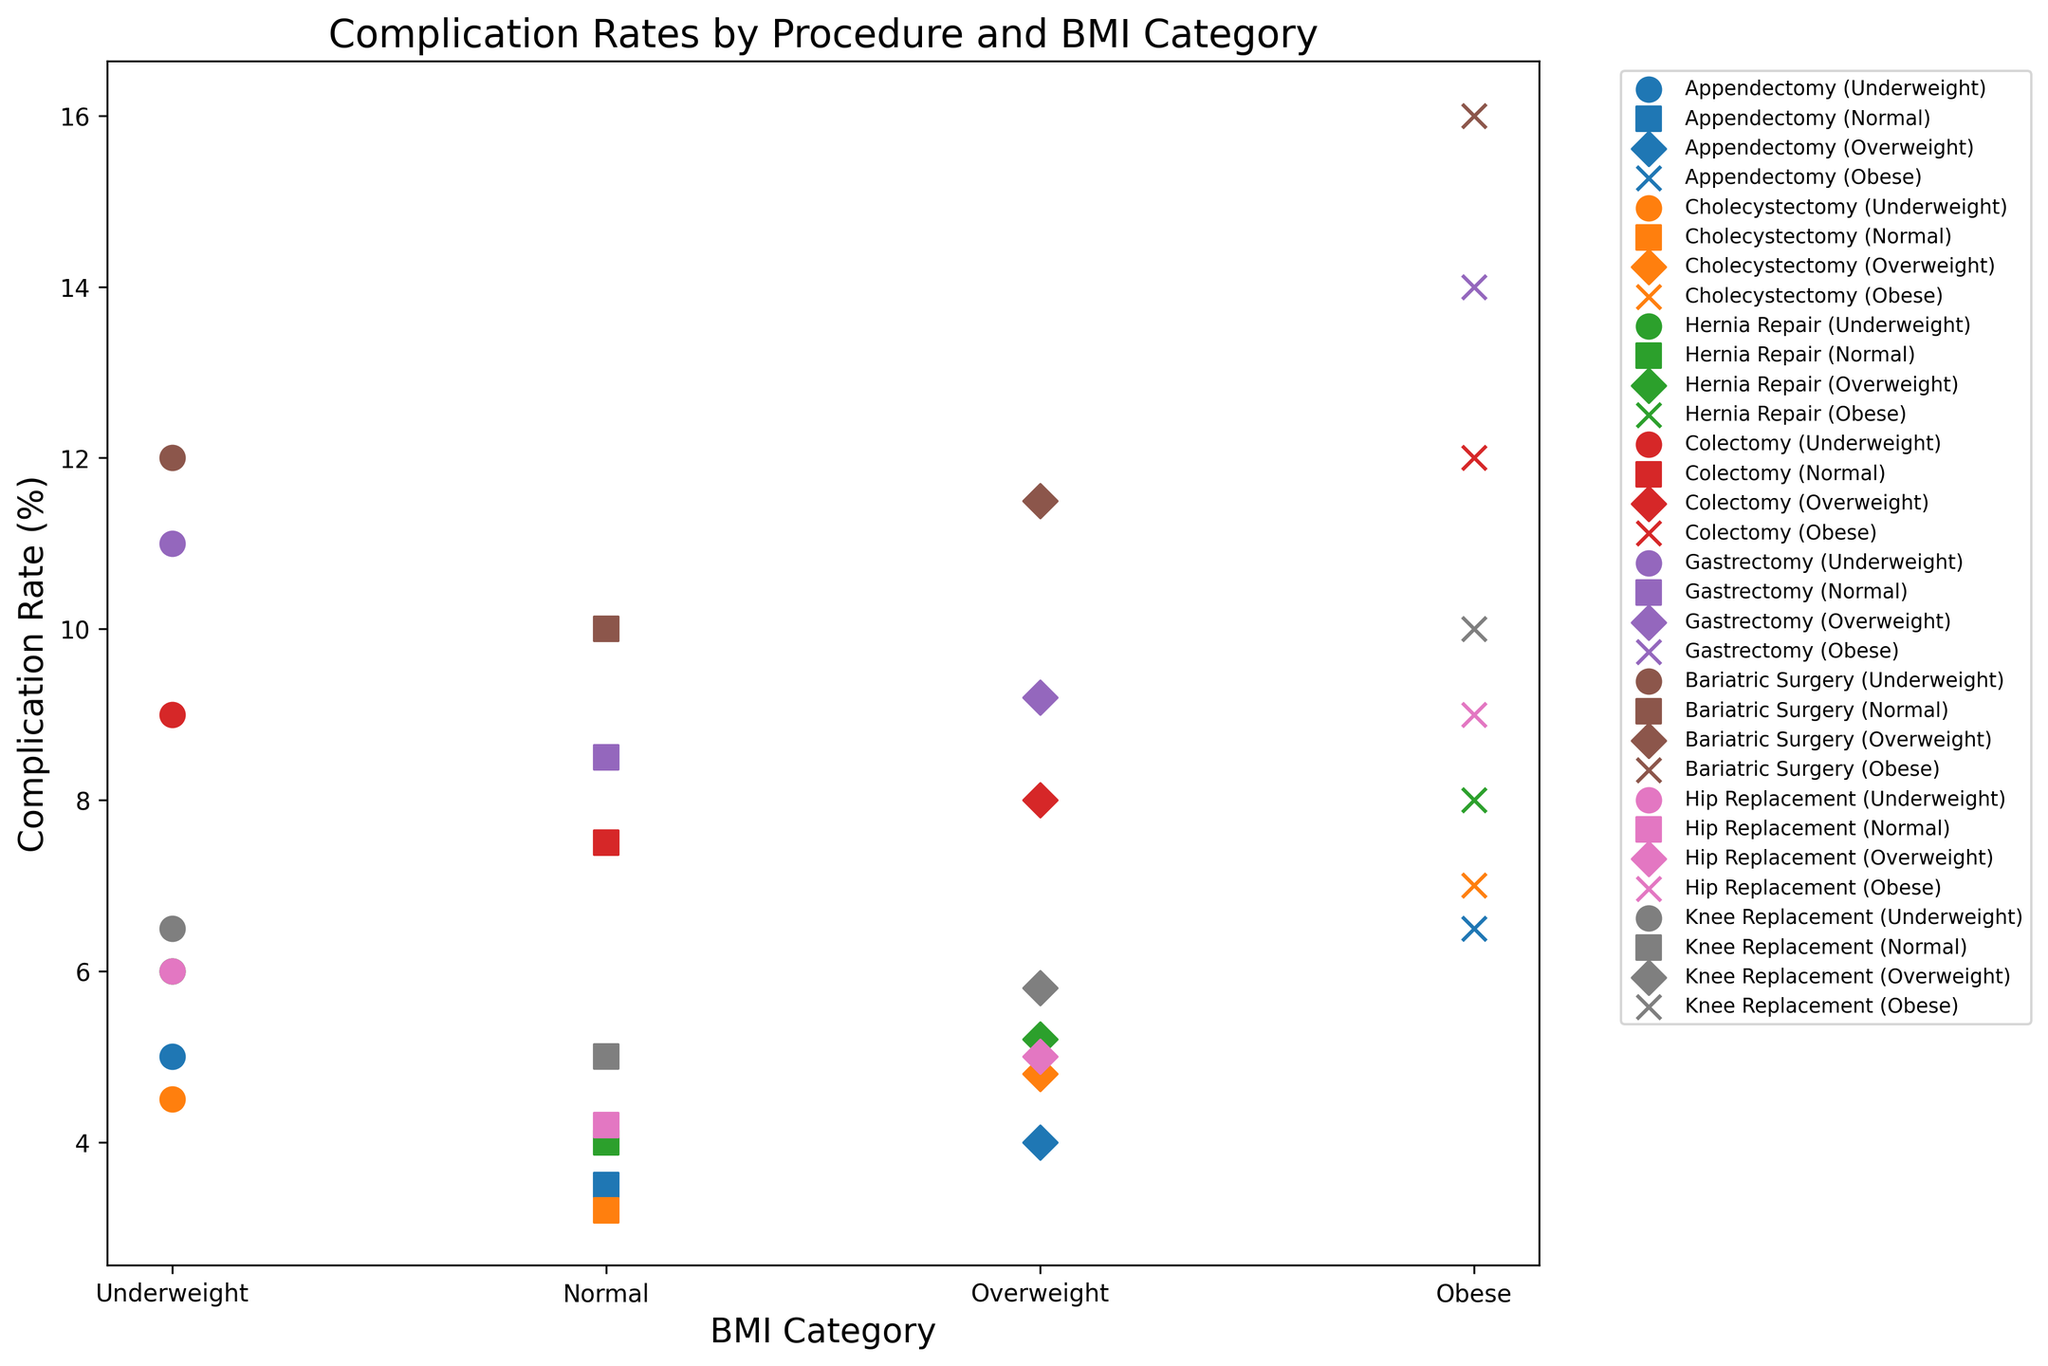Which BMI category has the highest complication rate for Gastrectomy? To answer this, locate the Gastrectomy data points in the cluster plot, and then compare the complication rates across the different BMI categories (Underweight, Normal, Overweight, Obese). Identify the category with the highest rate.
Answer: Obese Which procedure type shows the lowest complication rate in the Normal BMI category? Locate the data points for Normal BMI across different procedure types in the cluster plot. Compare the complication rates and find the one with the lowest value.
Answer: Cholecystectomy Among Appendectomy and Cholecystectomy, which procedure exhibits the highest complication rate for Overweight BMI? Compare the complication rates for Overweight BMI between Appendectomy and Cholecystectomy shown in the plot. Identify which one is higher.
Answer: Cholecystectomy How does the complication rate for Colectomy in the Normal BMI category compare to the rate for Hip Replacement in the same BMI category? Locate the complication rates for Colectomy and Hip Replacement in the Normal BMI category in the plot. Compare the two values.
Answer: Colectomy has a higher complication rate Which procedure type has the greatest difference in complication rates between the Underweight and Obese BMI categories? Calculate the difference in complication rates between Underweight and Obese BMI categories for each procedure. Identify the procedure with the largest difference.
Answer: Gastrectomy What is the average complication rate for Hip Replacement across all BMI categories? Sum the complication rates for Hip Replacement across all BMI categories and divide by the number of categories. The complication rates are 6.0 (Underweight), 4.2 (Normal), 5.0 (Overweight), and 9.0 (Obese). Average = (6.0 + 4.2 + 5.0 + 9.0) / 4
Answer: 6.05 Which BMI category tends to have the highest complication rates across all procedures, and which category the lowest? Compare the complication rates for each BMI category across all procedures. Find the average or typical rates for each category to identify trends.
Answer: Highest: Obese, Lowest: Normal For Bariatric Surgery, how much higher is the complication rate for Obese patients compared to Normal BMI patients? Locate the complication rates for Bariatric Surgery in the plot for Obese and Normal BMI categories. Subtract the Normal BMI rate from the Obese BMI rate. The rates are 16.0 (Obese) and 10.0 (Normal). Difference = 16.0 - 10.0
Answer: 6.0 How does the variation in complication rates across BMI categories for Knee Replacement compare to that of Colectomy? Identify the range (maximum rate - minimum rate) for each procedure by BMI category in the plot. For Knee Replacement: the rates are 6.5 (Underweight), 5.0 (Normal), 5.8 (Overweight), and 10.0 (Obese). Range for Knee Replacement = 10.0 - 5.0 = 5.0. For Colectomy: the rates are 9.0 (Underweight), 7.5 (Normal), 8.0 (Overweight), and 12.0 (Obese). Range for Colectomy = 12.0 - 7.5 = 4.5. Compare these ranges.
Answer: Similar, Knee Replacement: 5.0, Colectomy: 4.5 